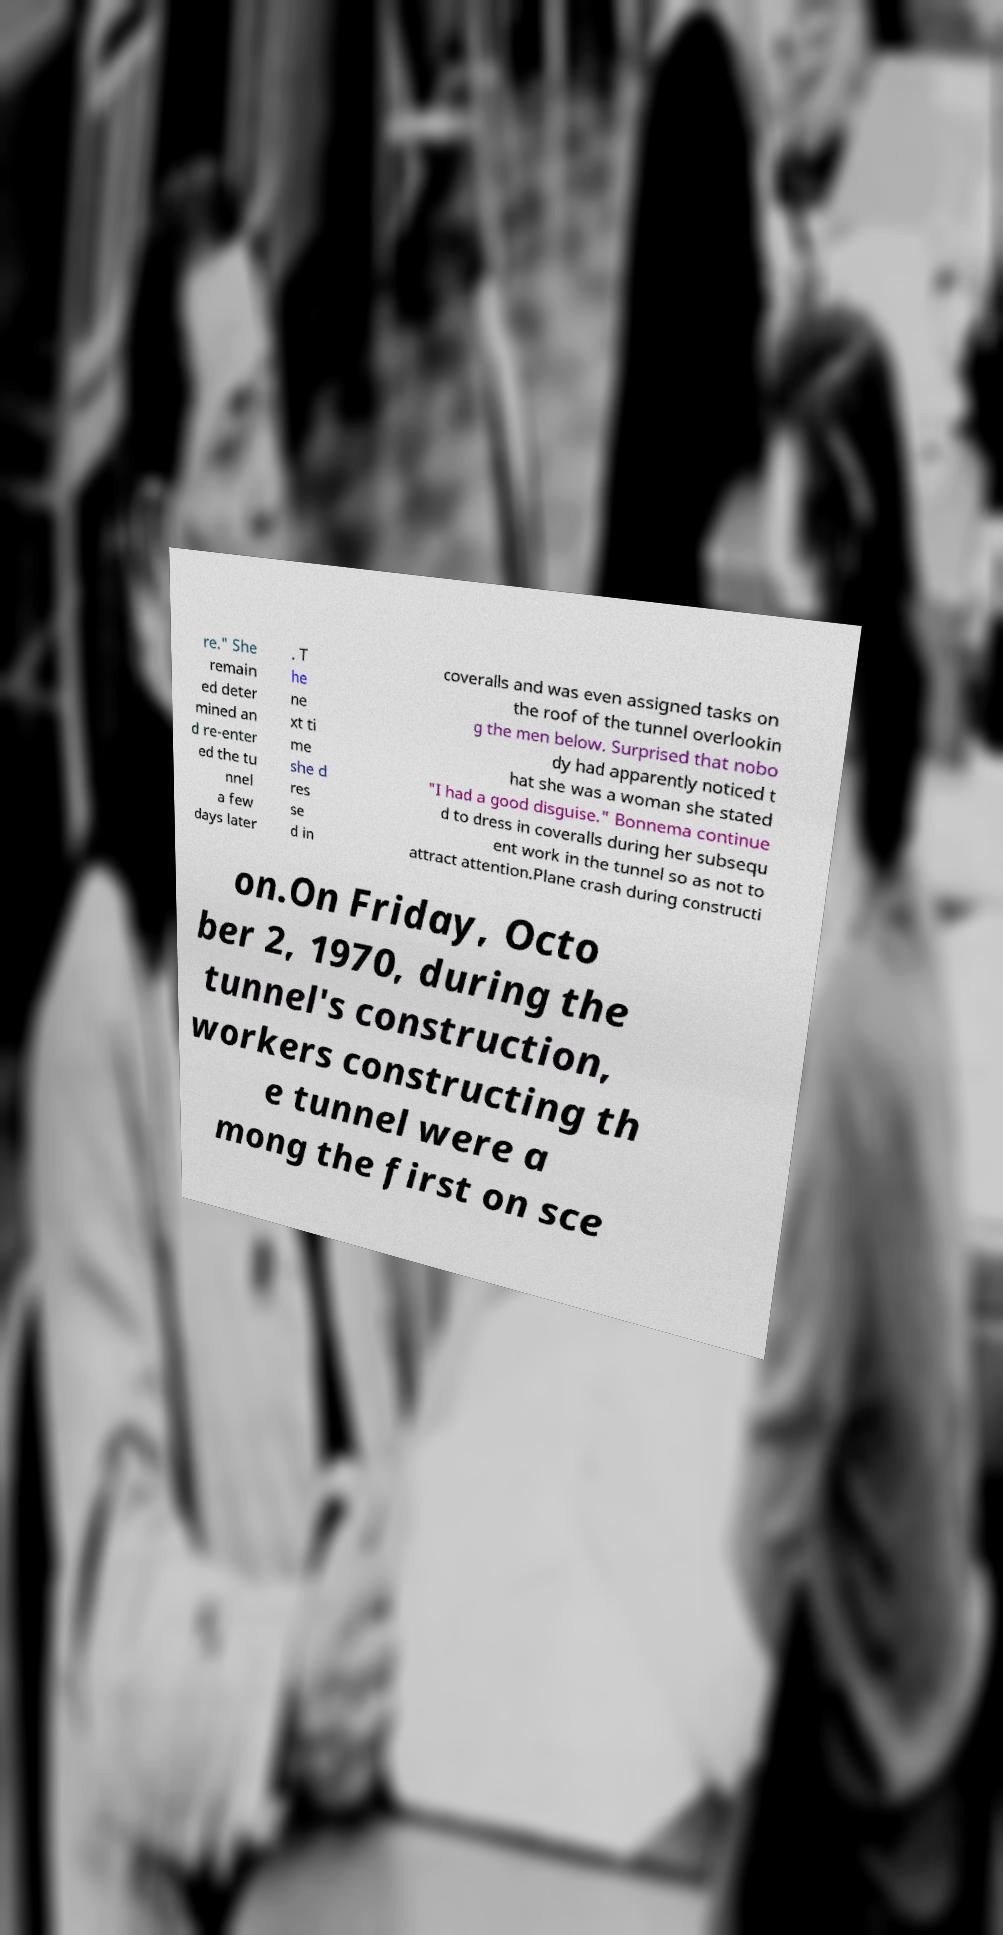Please identify and transcribe the text found in this image. re." She remain ed deter mined an d re-enter ed the tu nnel a few days later . T he ne xt ti me she d res se d in coveralls and was even assigned tasks on the roof of the tunnel overlookin g the men below. Surprised that nobo dy had apparently noticed t hat she was a woman she stated "I had a good disguise." Bonnema continue d to dress in coveralls during her subsequ ent work in the tunnel so as not to attract attention.Plane crash during constructi on.On Friday, Octo ber 2, 1970, during the tunnel's construction, workers constructing th e tunnel were a mong the first on sce 